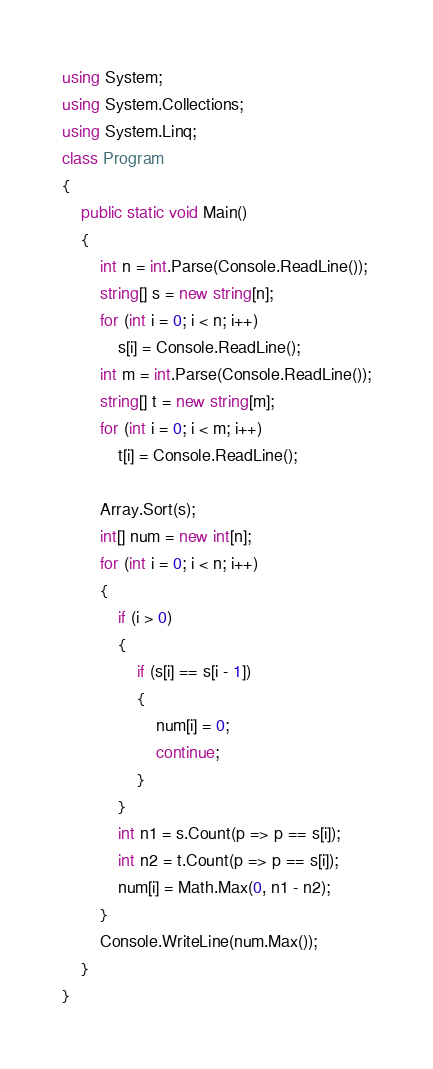Convert code to text. <code><loc_0><loc_0><loc_500><loc_500><_C#_>using System;
using System.Collections;
using System.Linq;
class Program
{
    public static void Main()
    {
        int n = int.Parse(Console.ReadLine());
        string[] s = new string[n];
        for (int i = 0; i < n; i++)
            s[i] = Console.ReadLine();
        int m = int.Parse(Console.ReadLine());
        string[] t = new string[m];
        for (int i = 0; i < m; i++)
            t[i] = Console.ReadLine();

        Array.Sort(s);
        int[] num = new int[n];
        for (int i = 0; i < n; i++)
        {
            if (i > 0)
            {
                if (s[i] == s[i - 1])
                {
                    num[i] = 0;
                    continue;
                }
            }
            int n1 = s.Count(p => p == s[i]);
            int n2 = t.Count(p => p == s[i]);
            num[i] = Math.Max(0, n1 - n2);
        }
        Console.WriteLine(num.Max());
    }
}</code> 